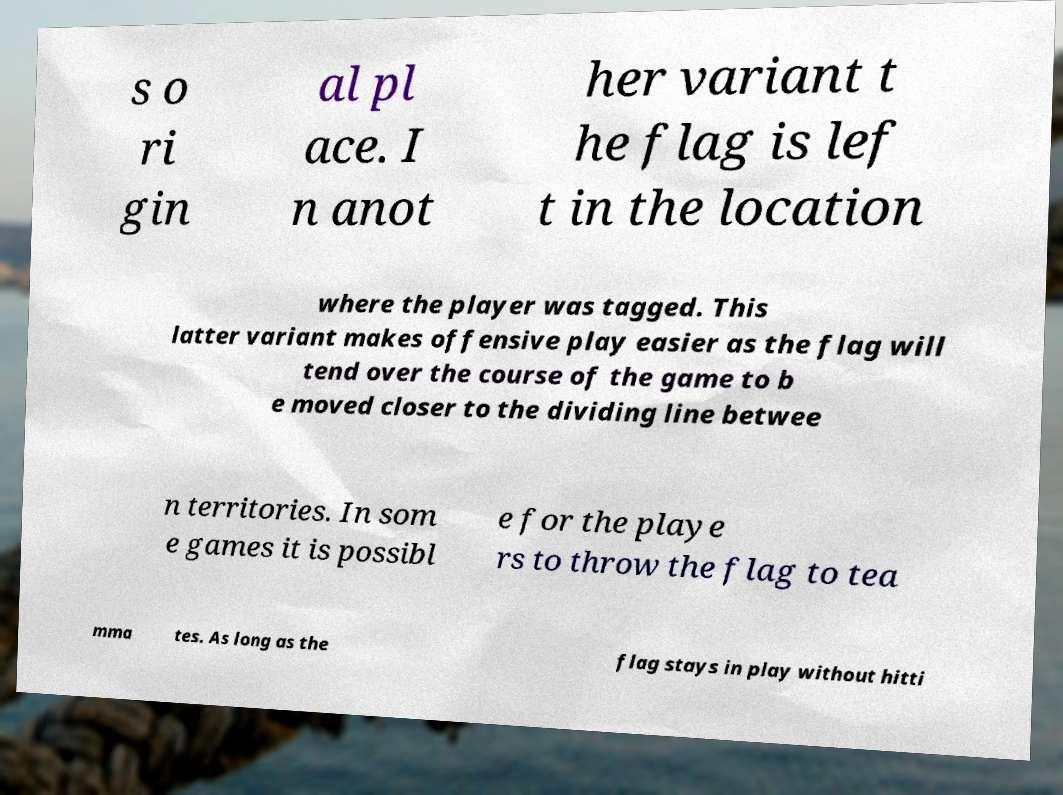What messages or text are displayed in this image? I need them in a readable, typed format. s o ri gin al pl ace. I n anot her variant t he flag is lef t in the location where the player was tagged. This latter variant makes offensive play easier as the flag will tend over the course of the game to b e moved closer to the dividing line betwee n territories. In som e games it is possibl e for the playe rs to throw the flag to tea mma tes. As long as the flag stays in play without hitti 